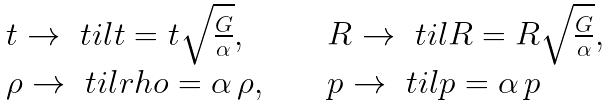Convert formula to latex. <formula><loc_0><loc_0><loc_500><loc_500>\begin{array} { l c l } t \to \ t i l t = t \sqrt { \frac { G } { \alpha } } , & \quad & R \to \ t i l R = R \sqrt { \frac { G } { \alpha } } , \\ \rho \to \ t i l r h o = \alpha \, \rho , & & p \to \ t i l p = \alpha \, p \end{array}</formula> 